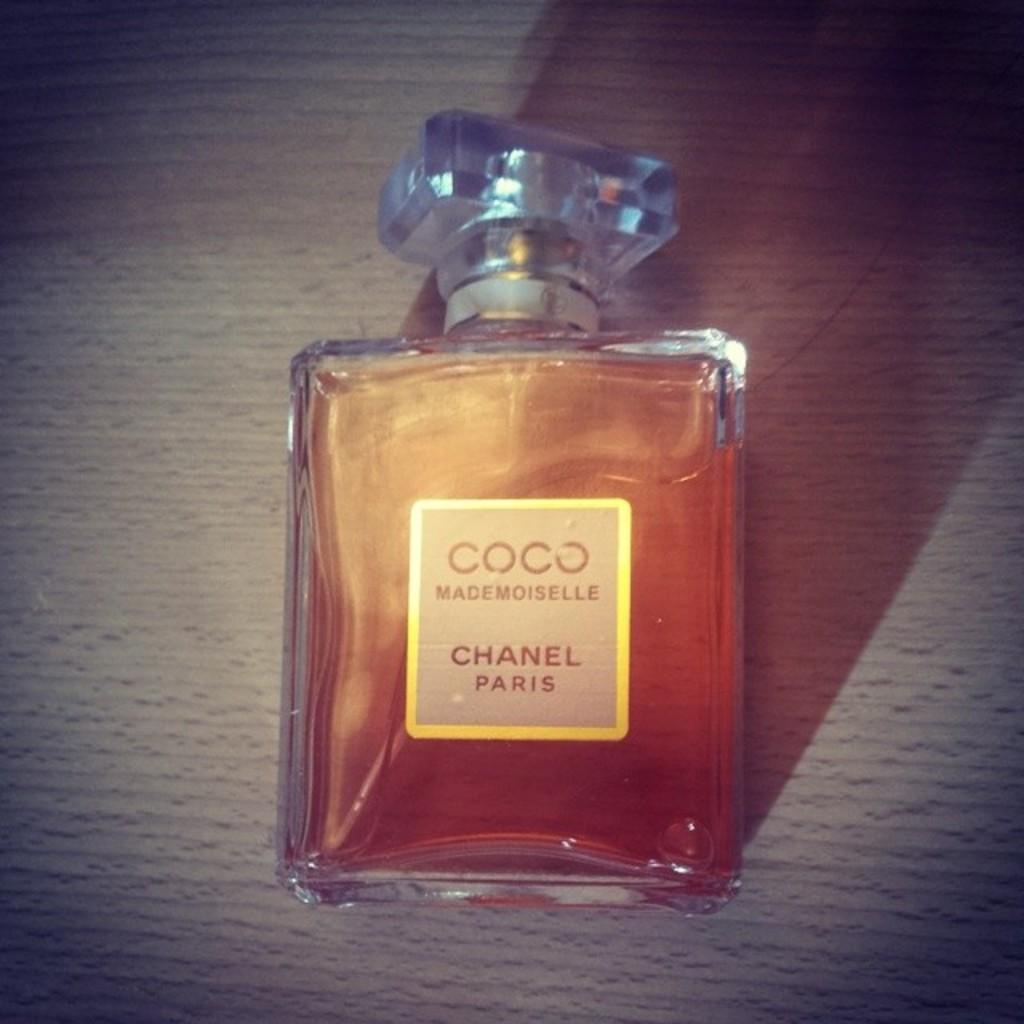<image>
Relay a brief, clear account of the picture shown. A full bottle of Coco Chanel perfume laying on a table. 